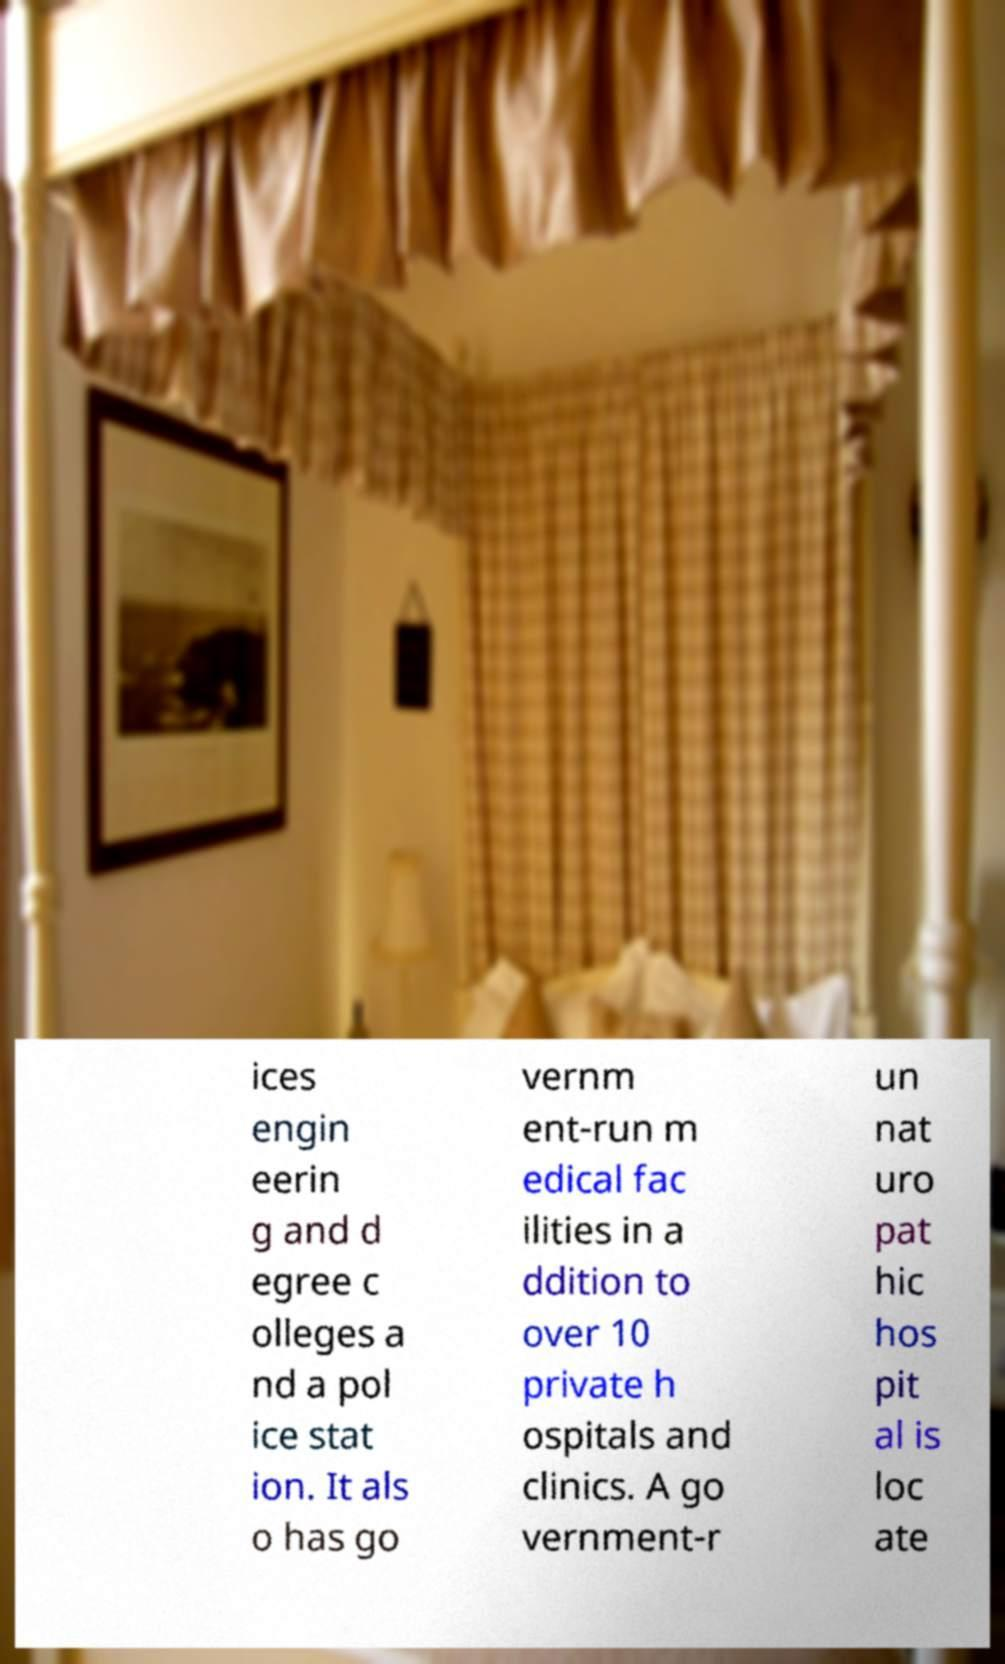For documentation purposes, I need the text within this image transcribed. Could you provide that? ices engin eerin g and d egree c olleges a nd a pol ice stat ion. It als o has go vernm ent-run m edical fac ilities in a ddition to over 10 private h ospitals and clinics. A go vernment-r un nat uro pat hic hos pit al is loc ate 